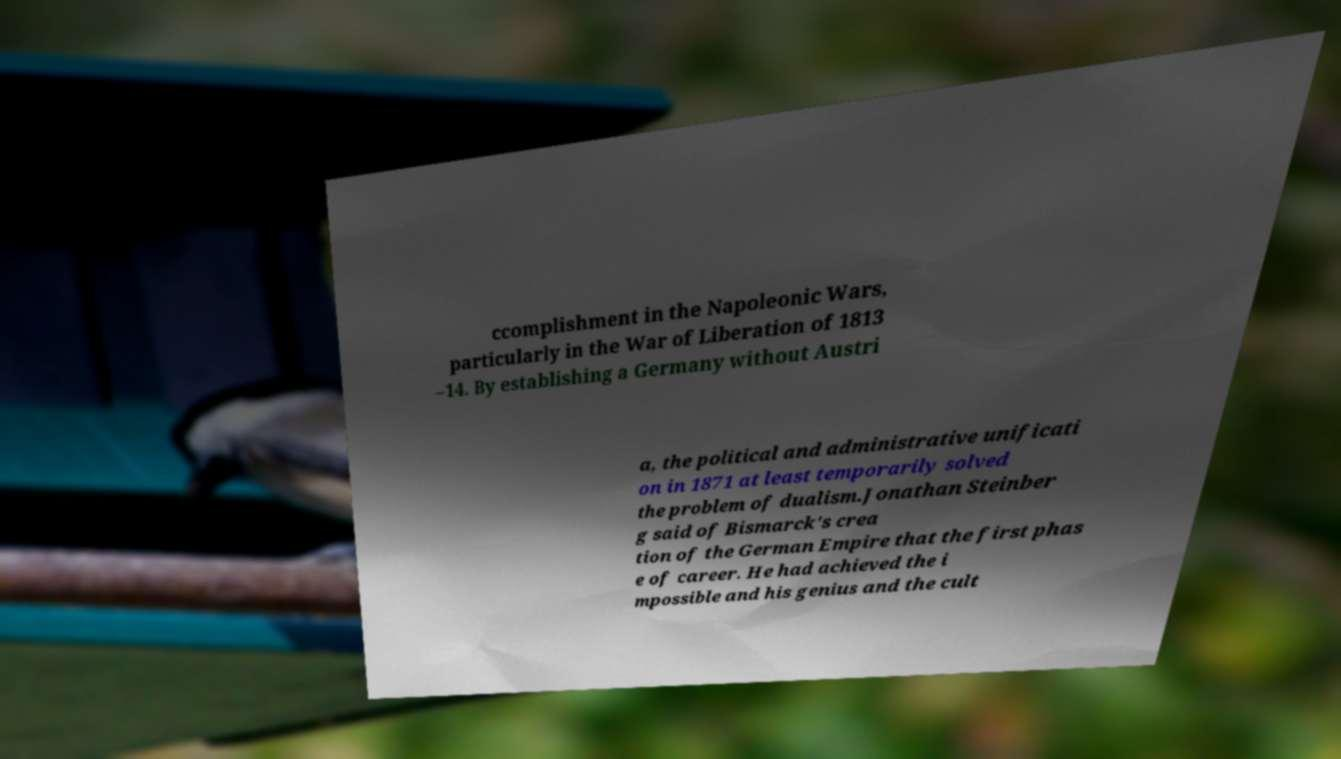Could you extract and type out the text from this image? ccomplishment in the Napoleonic Wars, particularly in the War of Liberation of 1813 –14. By establishing a Germany without Austri a, the political and administrative unificati on in 1871 at least temporarily solved the problem of dualism.Jonathan Steinber g said of Bismarck's crea tion of the German Empire that the first phas e of career. He had achieved the i mpossible and his genius and the cult 